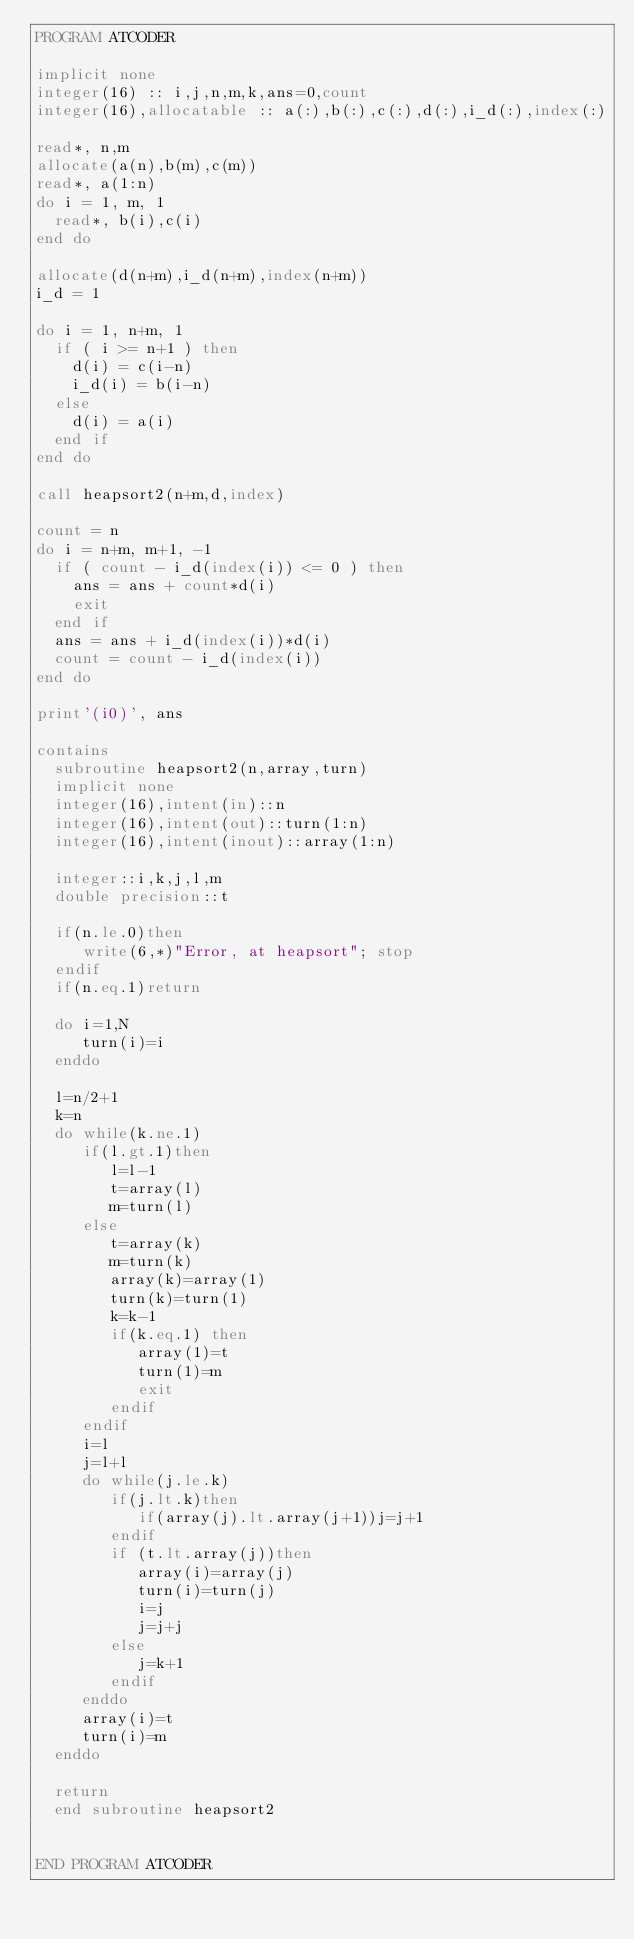<code> <loc_0><loc_0><loc_500><loc_500><_FORTRAN_>PROGRAM ATCODER

implicit none
integer(16) :: i,j,n,m,k,ans=0,count
integer(16),allocatable :: a(:),b(:),c(:),d(:),i_d(:),index(:)

read*, n,m 
allocate(a(n),b(m),c(m))
read*, a(1:n)
do i = 1, m, 1
  read*, b(i),c(i)
end do

allocate(d(n+m),i_d(n+m),index(n+m))
i_d = 1

do i = 1, n+m, 1
  if ( i >= n+1 ) then
    d(i) = c(i-n)
    i_d(i) = b(i-n)
  else
    d(i) = a(i)
  end if
end do

call heapsort2(n+m,d,index)

count = n
do i = n+m, m+1, -1
  if ( count - i_d(index(i)) <= 0 ) then
    ans = ans + count*d(i)
    exit
  end if
  ans = ans + i_d(index(i))*d(i)
  count = count - i_d(index(i))
end do

print'(i0)', ans

contains
  subroutine heapsort2(n,array,turn)
  implicit none
  integer(16),intent(in)::n
  integer(16),intent(out)::turn(1:n)
  integer(16),intent(inout)::array(1:n)
  
  integer::i,k,j,l,m
  double precision::t
  
  if(n.le.0)then
     write(6,*)"Error, at heapsort"; stop
  endif
  if(n.eq.1)return

  do i=1,N
     turn(i)=i
  enddo

  l=n/2+1
  k=n
  do while(k.ne.1)
     if(l.gt.1)then
        l=l-1
        t=array(l)
        m=turn(l)
     else
        t=array(k)
        m=turn(k)
        array(k)=array(1)
        turn(k)=turn(1)
        k=k-1
        if(k.eq.1) then
           array(1)=t
           turn(1)=m
           exit
        endif
     endif
     i=l
     j=l+l
     do while(j.le.k)
        if(j.lt.k)then
           if(array(j).lt.array(j+1))j=j+1
        endif
        if (t.lt.array(j))then
           array(i)=array(j)
           turn(i)=turn(j)
           i=j
           j=j+j
        else
           j=k+1
        endif
     enddo
     array(i)=t
     turn(i)=m
  enddo

  return
  end subroutine heapsort2


END PROGRAM ATCODER</code> 